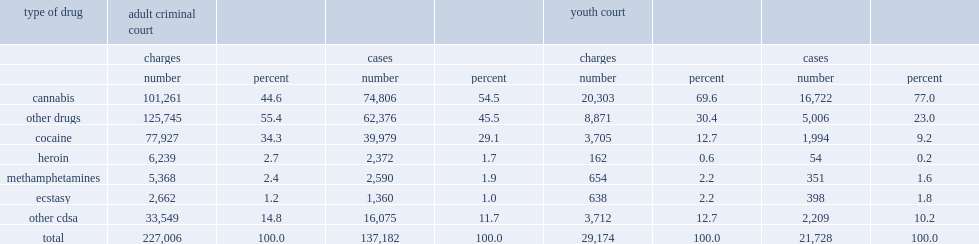From 2008/2009 to 2011/2012, there were 158,910 completed criminal court cases where at least one charge in the case was drug-related and where the court record could be linked to a police-reported incident record. how many cases were adult criminal cases? 137182.0. From 2008/2009 to 2011/2012, there were 158,910 completed criminal court cases where at least one charge in the case was drug-related and where the court record could be linked to a police-reported incident record. how many cases were youth cases? 21728.0. Similar to findings from police-reported data, the majority of these completed drug-related cases in adult criminal courts were related to cannabis, what is the percentage of completed adult drug-related cases from 2008/2009 to 2011/2012? 54.5. Similar to findings from police-reported data, the majority of these completed drug-related cases in youth courts were related to cannabis, what is the percentage of completed youth drug-related cases from 2008/2009 to 2011/2012? 77.0. What is the percentage of completed adult drug-related cases involved cocaine from 2008/2009 to 2011/2012? 29.1. What is the percentage of completed drug-related cases in youth court involved cocaine from 2008/2009 to 2011/2012? 9.2. What is the proportions for methamphetamines of all completed cases for adult criminal from 2008/2009 to 2011/2012? 1.9. What is the proportions for methamphetamines of all completed cases for youth court from 2008/2009 to 2011/2012? 1.6. 